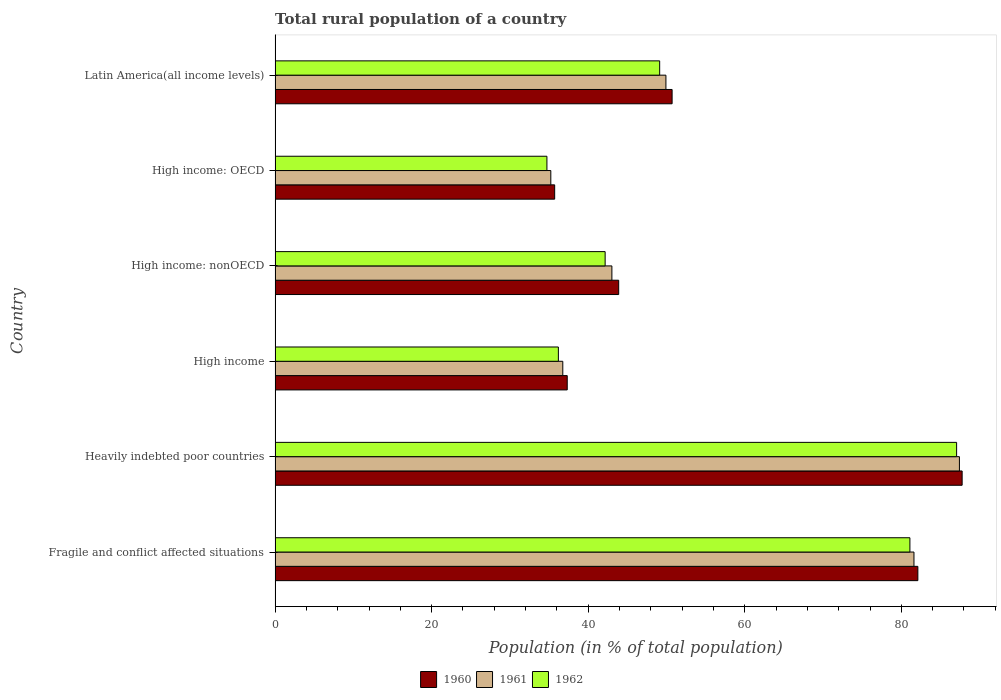How many groups of bars are there?
Your response must be concise. 6. Are the number of bars per tick equal to the number of legend labels?
Provide a short and direct response. Yes. How many bars are there on the 2nd tick from the top?
Make the answer very short. 3. What is the label of the 1st group of bars from the top?
Your answer should be very brief. Latin America(all income levels). What is the rural population in 1960 in Latin America(all income levels)?
Your response must be concise. 50.72. Across all countries, what is the maximum rural population in 1960?
Make the answer very short. 87.76. Across all countries, what is the minimum rural population in 1962?
Your answer should be very brief. 34.72. In which country was the rural population in 1962 maximum?
Offer a very short reply. Heavily indebted poor countries. In which country was the rural population in 1961 minimum?
Offer a terse response. High income: OECD. What is the total rural population in 1960 in the graph?
Ensure brevity in your answer.  337.51. What is the difference between the rural population in 1961 in High income: OECD and that in High income: nonOECD?
Offer a very short reply. -7.8. What is the difference between the rural population in 1961 in High income and the rural population in 1960 in Latin America(all income levels)?
Give a very brief answer. -13.96. What is the average rural population in 1962 per country?
Provide a succinct answer. 55.06. What is the difference between the rural population in 1961 and rural population in 1960 in High income: nonOECD?
Provide a succinct answer. -0.87. In how many countries, is the rural population in 1961 greater than 24 %?
Your answer should be compact. 6. What is the ratio of the rural population in 1962 in Fragile and conflict affected situations to that in Latin America(all income levels)?
Provide a short and direct response. 1.65. What is the difference between the highest and the second highest rural population in 1962?
Your answer should be compact. 5.97. What is the difference between the highest and the lowest rural population in 1960?
Offer a very short reply. 52.05. What does the 2nd bar from the top in High income: nonOECD represents?
Your response must be concise. 1961. What does the 3rd bar from the bottom in Fragile and conflict affected situations represents?
Offer a very short reply. 1962. Is it the case that in every country, the sum of the rural population in 1962 and rural population in 1960 is greater than the rural population in 1961?
Your response must be concise. Yes. Are all the bars in the graph horizontal?
Provide a succinct answer. Yes. How many countries are there in the graph?
Your answer should be compact. 6. Are the values on the major ticks of X-axis written in scientific E-notation?
Offer a very short reply. No. Does the graph contain any zero values?
Give a very brief answer. No. Does the graph contain grids?
Give a very brief answer. No. Where does the legend appear in the graph?
Offer a very short reply. Bottom center. What is the title of the graph?
Ensure brevity in your answer.  Total rural population of a country. What is the label or title of the X-axis?
Ensure brevity in your answer.  Population (in % of total population). What is the label or title of the Y-axis?
Make the answer very short. Country. What is the Population (in % of total population) in 1960 in Fragile and conflict affected situations?
Offer a very short reply. 82.11. What is the Population (in % of total population) of 1961 in Fragile and conflict affected situations?
Make the answer very short. 81.61. What is the Population (in % of total population) in 1962 in Fragile and conflict affected situations?
Offer a very short reply. 81.09. What is the Population (in % of total population) of 1960 in Heavily indebted poor countries?
Offer a terse response. 87.76. What is the Population (in % of total population) in 1961 in Heavily indebted poor countries?
Make the answer very short. 87.42. What is the Population (in % of total population) in 1962 in Heavily indebted poor countries?
Make the answer very short. 87.06. What is the Population (in % of total population) of 1960 in High income?
Your answer should be compact. 37.32. What is the Population (in % of total population) in 1961 in High income?
Offer a terse response. 36.75. What is the Population (in % of total population) of 1962 in High income?
Your answer should be compact. 36.19. What is the Population (in % of total population) of 1960 in High income: nonOECD?
Your response must be concise. 43.89. What is the Population (in % of total population) in 1961 in High income: nonOECD?
Ensure brevity in your answer.  43.02. What is the Population (in % of total population) of 1962 in High income: nonOECD?
Offer a very short reply. 42.16. What is the Population (in % of total population) of 1960 in High income: OECD?
Your response must be concise. 35.71. What is the Population (in % of total population) of 1961 in High income: OECD?
Make the answer very short. 35.22. What is the Population (in % of total population) in 1962 in High income: OECD?
Your response must be concise. 34.72. What is the Population (in % of total population) in 1960 in Latin America(all income levels)?
Your answer should be very brief. 50.72. What is the Population (in % of total population) of 1961 in Latin America(all income levels)?
Ensure brevity in your answer.  49.93. What is the Population (in % of total population) in 1962 in Latin America(all income levels)?
Give a very brief answer. 49.13. Across all countries, what is the maximum Population (in % of total population) in 1960?
Provide a succinct answer. 87.76. Across all countries, what is the maximum Population (in % of total population) in 1961?
Make the answer very short. 87.42. Across all countries, what is the maximum Population (in % of total population) in 1962?
Make the answer very short. 87.06. Across all countries, what is the minimum Population (in % of total population) in 1960?
Your answer should be compact. 35.71. Across all countries, what is the minimum Population (in % of total population) in 1961?
Your answer should be very brief. 35.22. Across all countries, what is the minimum Population (in % of total population) of 1962?
Ensure brevity in your answer.  34.72. What is the total Population (in % of total population) of 1960 in the graph?
Keep it short and to the point. 337.51. What is the total Population (in % of total population) in 1961 in the graph?
Make the answer very short. 333.95. What is the total Population (in % of total population) of 1962 in the graph?
Your response must be concise. 330.35. What is the difference between the Population (in % of total population) of 1960 in Fragile and conflict affected situations and that in Heavily indebted poor countries?
Give a very brief answer. -5.66. What is the difference between the Population (in % of total population) of 1961 in Fragile and conflict affected situations and that in Heavily indebted poor countries?
Keep it short and to the point. -5.81. What is the difference between the Population (in % of total population) of 1962 in Fragile and conflict affected situations and that in Heavily indebted poor countries?
Your response must be concise. -5.97. What is the difference between the Population (in % of total population) of 1960 in Fragile and conflict affected situations and that in High income?
Ensure brevity in your answer.  44.79. What is the difference between the Population (in % of total population) in 1961 in Fragile and conflict affected situations and that in High income?
Give a very brief answer. 44.86. What is the difference between the Population (in % of total population) of 1962 in Fragile and conflict affected situations and that in High income?
Make the answer very short. 44.91. What is the difference between the Population (in % of total population) in 1960 in Fragile and conflict affected situations and that in High income: nonOECD?
Keep it short and to the point. 38.22. What is the difference between the Population (in % of total population) of 1961 in Fragile and conflict affected situations and that in High income: nonOECD?
Ensure brevity in your answer.  38.59. What is the difference between the Population (in % of total population) in 1962 in Fragile and conflict affected situations and that in High income: nonOECD?
Your answer should be compact. 38.93. What is the difference between the Population (in % of total population) of 1960 in Fragile and conflict affected situations and that in High income: OECD?
Give a very brief answer. 46.39. What is the difference between the Population (in % of total population) in 1961 in Fragile and conflict affected situations and that in High income: OECD?
Keep it short and to the point. 46.39. What is the difference between the Population (in % of total population) in 1962 in Fragile and conflict affected situations and that in High income: OECD?
Provide a short and direct response. 46.37. What is the difference between the Population (in % of total population) of 1960 in Fragile and conflict affected situations and that in Latin America(all income levels)?
Ensure brevity in your answer.  31.39. What is the difference between the Population (in % of total population) in 1961 in Fragile and conflict affected situations and that in Latin America(all income levels)?
Ensure brevity in your answer.  31.68. What is the difference between the Population (in % of total population) of 1962 in Fragile and conflict affected situations and that in Latin America(all income levels)?
Keep it short and to the point. 31.97. What is the difference between the Population (in % of total population) of 1960 in Heavily indebted poor countries and that in High income?
Keep it short and to the point. 50.44. What is the difference between the Population (in % of total population) in 1961 in Heavily indebted poor countries and that in High income?
Keep it short and to the point. 50.66. What is the difference between the Population (in % of total population) of 1962 in Heavily indebted poor countries and that in High income?
Provide a succinct answer. 50.87. What is the difference between the Population (in % of total population) of 1960 in Heavily indebted poor countries and that in High income: nonOECD?
Make the answer very short. 43.87. What is the difference between the Population (in % of total population) in 1961 in Heavily indebted poor countries and that in High income: nonOECD?
Your response must be concise. 44.39. What is the difference between the Population (in % of total population) of 1962 in Heavily indebted poor countries and that in High income: nonOECD?
Ensure brevity in your answer.  44.9. What is the difference between the Population (in % of total population) in 1960 in Heavily indebted poor countries and that in High income: OECD?
Ensure brevity in your answer.  52.05. What is the difference between the Population (in % of total population) of 1961 in Heavily indebted poor countries and that in High income: OECD?
Offer a terse response. 52.2. What is the difference between the Population (in % of total population) of 1962 in Heavily indebted poor countries and that in High income: OECD?
Provide a succinct answer. 52.33. What is the difference between the Population (in % of total population) in 1960 in Heavily indebted poor countries and that in Latin America(all income levels)?
Ensure brevity in your answer.  37.05. What is the difference between the Population (in % of total population) of 1961 in Heavily indebted poor countries and that in Latin America(all income levels)?
Provide a short and direct response. 37.49. What is the difference between the Population (in % of total population) in 1962 in Heavily indebted poor countries and that in Latin America(all income levels)?
Make the answer very short. 37.93. What is the difference between the Population (in % of total population) in 1960 in High income and that in High income: nonOECD?
Offer a terse response. -6.57. What is the difference between the Population (in % of total population) in 1961 in High income and that in High income: nonOECD?
Offer a very short reply. -6.27. What is the difference between the Population (in % of total population) in 1962 in High income and that in High income: nonOECD?
Provide a short and direct response. -5.97. What is the difference between the Population (in % of total population) in 1960 in High income and that in High income: OECD?
Provide a succinct answer. 1.61. What is the difference between the Population (in % of total population) of 1961 in High income and that in High income: OECD?
Give a very brief answer. 1.53. What is the difference between the Population (in % of total population) in 1962 in High income and that in High income: OECD?
Provide a succinct answer. 1.46. What is the difference between the Population (in % of total population) in 1960 in High income and that in Latin America(all income levels)?
Keep it short and to the point. -13.4. What is the difference between the Population (in % of total population) in 1961 in High income and that in Latin America(all income levels)?
Ensure brevity in your answer.  -13.17. What is the difference between the Population (in % of total population) of 1962 in High income and that in Latin America(all income levels)?
Offer a very short reply. -12.94. What is the difference between the Population (in % of total population) of 1960 in High income: nonOECD and that in High income: OECD?
Keep it short and to the point. 8.18. What is the difference between the Population (in % of total population) of 1961 in High income: nonOECD and that in High income: OECD?
Offer a very short reply. 7.8. What is the difference between the Population (in % of total population) in 1962 in High income: nonOECD and that in High income: OECD?
Keep it short and to the point. 7.44. What is the difference between the Population (in % of total population) of 1960 in High income: nonOECD and that in Latin America(all income levels)?
Keep it short and to the point. -6.82. What is the difference between the Population (in % of total population) of 1961 in High income: nonOECD and that in Latin America(all income levels)?
Offer a terse response. -6.9. What is the difference between the Population (in % of total population) of 1962 in High income: nonOECD and that in Latin America(all income levels)?
Ensure brevity in your answer.  -6.97. What is the difference between the Population (in % of total population) in 1960 in High income: OECD and that in Latin America(all income levels)?
Your answer should be compact. -15. What is the difference between the Population (in % of total population) of 1961 in High income: OECD and that in Latin America(all income levels)?
Keep it short and to the point. -14.71. What is the difference between the Population (in % of total population) of 1962 in High income: OECD and that in Latin America(all income levels)?
Offer a very short reply. -14.4. What is the difference between the Population (in % of total population) of 1960 in Fragile and conflict affected situations and the Population (in % of total population) of 1961 in Heavily indebted poor countries?
Provide a succinct answer. -5.31. What is the difference between the Population (in % of total population) of 1960 in Fragile and conflict affected situations and the Population (in % of total population) of 1962 in Heavily indebted poor countries?
Your answer should be compact. -4.95. What is the difference between the Population (in % of total population) in 1961 in Fragile and conflict affected situations and the Population (in % of total population) in 1962 in Heavily indebted poor countries?
Make the answer very short. -5.45. What is the difference between the Population (in % of total population) of 1960 in Fragile and conflict affected situations and the Population (in % of total population) of 1961 in High income?
Give a very brief answer. 45.35. What is the difference between the Population (in % of total population) in 1960 in Fragile and conflict affected situations and the Population (in % of total population) in 1962 in High income?
Your answer should be very brief. 45.92. What is the difference between the Population (in % of total population) of 1961 in Fragile and conflict affected situations and the Population (in % of total population) of 1962 in High income?
Offer a very short reply. 45.42. What is the difference between the Population (in % of total population) of 1960 in Fragile and conflict affected situations and the Population (in % of total population) of 1961 in High income: nonOECD?
Your response must be concise. 39.08. What is the difference between the Population (in % of total population) of 1960 in Fragile and conflict affected situations and the Population (in % of total population) of 1962 in High income: nonOECD?
Ensure brevity in your answer.  39.95. What is the difference between the Population (in % of total population) in 1961 in Fragile and conflict affected situations and the Population (in % of total population) in 1962 in High income: nonOECD?
Make the answer very short. 39.45. What is the difference between the Population (in % of total population) in 1960 in Fragile and conflict affected situations and the Population (in % of total population) in 1961 in High income: OECD?
Give a very brief answer. 46.89. What is the difference between the Population (in % of total population) of 1960 in Fragile and conflict affected situations and the Population (in % of total population) of 1962 in High income: OECD?
Keep it short and to the point. 47.38. What is the difference between the Population (in % of total population) of 1961 in Fragile and conflict affected situations and the Population (in % of total population) of 1962 in High income: OECD?
Make the answer very short. 46.89. What is the difference between the Population (in % of total population) in 1960 in Fragile and conflict affected situations and the Population (in % of total population) in 1961 in Latin America(all income levels)?
Your response must be concise. 32.18. What is the difference between the Population (in % of total population) in 1960 in Fragile and conflict affected situations and the Population (in % of total population) in 1962 in Latin America(all income levels)?
Offer a terse response. 32.98. What is the difference between the Population (in % of total population) in 1961 in Fragile and conflict affected situations and the Population (in % of total population) in 1962 in Latin America(all income levels)?
Your answer should be very brief. 32.48. What is the difference between the Population (in % of total population) in 1960 in Heavily indebted poor countries and the Population (in % of total population) in 1961 in High income?
Give a very brief answer. 51.01. What is the difference between the Population (in % of total population) of 1960 in Heavily indebted poor countries and the Population (in % of total population) of 1962 in High income?
Provide a succinct answer. 51.58. What is the difference between the Population (in % of total population) of 1961 in Heavily indebted poor countries and the Population (in % of total population) of 1962 in High income?
Give a very brief answer. 51.23. What is the difference between the Population (in % of total population) of 1960 in Heavily indebted poor countries and the Population (in % of total population) of 1961 in High income: nonOECD?
Ensure brevity in your answer.  44.74. What is the difference between the Population (in % of total population) in 1960 in Heavily indebted poor countries and the Population (in % of total population) in 1962 in High income: nonOECD?
Your answer should be compact. 45.6. What is the difference between the Population (in % of total population) in 1961 in Heavily indebted poor countries and the Population (in % of total population) in 1962 in High income: nonOECD?
Give a very brief answer. 45.26. What is the difference between the Population (in % of total population) of 1960 in Heavily indebted poor countries and the Population (in % of total population) of 1961 in High income: OECD?
Give a very brief answer. 52.54. What is the difference between the Population (in % of total population) in 1960 in Heavily indebted poor countries and the Population (in % of total population) in 1962 in High income: OECD?
Keep it short and to the point. 53.04. What is the difference between the Population (in % of total population) of 1961 in Heavily indebted poor countries and the Population (in % of total population) of 1962 in High income: OECD?
Provide a short and direct response. 52.69. What is the difference between the Population (in % of total population) of 1960 in Heavily indebted poor countries and the Population (in % of total population) of 1961 in Latin America(all income levels)?
Your answer should be compact. 37.84. What is the difference between the Population (in % of total population) of 1960 in Heavily indebted poor countries and the Population (in % of total population) of 1962 in Latin America(all income levels)?
Ensure brevity in your answer.  38.64. What is the difference between the Population (in % of total population) in 1961 in Heavily indebted poor countries and the Population (in % of total population) in 1962 in Latin America(all income levels)?
Make the answer very short. 38.29. What is the difference between the Population (in % of total population) in 1960 in High income and the Population (in % of total population) in 1961 in High income: nonOECD?
Offer a very short reply. -5.7. What is the difference between the Population (in % of total population) of 1960 in High income and the Population (in % of total population) of 1962 in High income: nonOECD?
Keep it short and to the point. -4.84. What is the difference between the Population (in % of total population) of 1961 in High income and the Population (in % of total population) of 1962 in High income: nonOECD?
Offer a very short reply. -5.41. What is the difference between the Population (in % of total population) of 1960 in High income and the Population (in % of total population) of 1961 in High income: OECD?
Ensure brevity in your answer.  2.1. What is the difference between the Population (in % of total population) of 1960 in High income and the Population (in % of total population) of 1962 in High income: OECD?
Provide a short and direct response. 2.6. What is the difference between the Population (in % of total population) of 1961 in High income and the Population (in % of total population) of 1962 in High income: OECD?
Your answer should be very brief. 2.03. What is the difference between the Population (in % of total population) in 1960 in High income and the Population (in % of total population) in 1961 in Latin America(all income levels)?
Provide a succinct answer. -12.61. What is the difference between the Population (in % of total population) of 1960 in High income and the Population (in % of total population) of 1962 in Latin America(all income levels)?
Your answer should be very brief. -11.81. What is the difference between the Population (in % of total population) of 1961 in High income and the Population (in % of total population) of 1962 in Latin America(all income levels)?
Offer a terse response. -12.37. What is the difference between the Population (in % of total population) of 1960 in High income: nonOECD and the Population (in % of total population) of 1961 in High income: OECD?
Provide a short and direct response. 8.67. What is the difference between the Population (in % of total population) in 1960 in High income: nonOECD and the Population (in % of total population) in 1962 in High income: OECD?
Offer a very short reply. 9.17. What is the difference between the Population (in % of total population) of 1961 in High income: nonOECD and the Population (in % of total population) of 1962 in High income: OECD?
Your answer should be very brief. 8.3. What is the difference between the Population (in % of total population) of 1960 in High income: nonOECD and the Population (in % of total population) of 1961 in Latin America(all income levels)?
Give a very brief answer. -6.03. What is the difference between the Population (in % of total population) in 1960 in High income: nonOECD and the Population (in % of total population) in 1962 in Latin America(all income levels)?
Ensure brevity in your answer.  -5.24. What is the difference between the Population (in % of total population) of 1961 in High income: nonOECD and the Population (in % of total population) of 1962 in Latin America(all income levels)?
Ensure brevity in your answer.  -6.1. What is the difference between the Population (in % of total population) of 1960 in High income: OECD and the Population (in % of total population) of 1961 in Latin America(all income levels)?
Offer a terse response. -14.21. What is the difference between the Population (in % of total population) in 1960 in High income: OECD and the Population (in % of total population) in 1962 in Latin America(all income levels)?
Your response must be concise. -13.41. What is the difference between the Population (in % of total population) in 1961 in High income: OECD and the Population (in % of total population) in 1962 in Latin America(all income levels)?
Provide a short and direct response. -13.91. What is the average Population (in % of total population) in 1960 per country?
Offer a terse response. 56.25. What is the average Population (in % of total population) of 1961 per country?
Provide a short and direct response. 55.66. What is the average Population (in % of total population) in 1962 per country?
Keep it short and to the point. 55.06. What is the difference between the Population (in % of total population) in 1960 and Population (in % of total population) in 1961 in Fragile and conflict affected situations?
Make the answer very short. 0.5. What is the difference between the Population (in % of total population) in 1960 and Population (in % of total population) in 1962 in Fragile and conflict affected situations?
Provide a short and direct response. 1.02. What is the difference between the Population (in % of total population) of 1961 and Population (in % of total population) of 1962 in Fragile and conflict affected situations?
Make the answer very short. 0.52. What is the difference between the Population (in % of total population) in 1960 and Population (in % of total population) in 1961 in Heavily indebted poor countries?
Provide a succinct answer. 0.35. What is the difference between the Population (in % of total population) of 1960 and Population (in % of total population) of 1962 in Heavily indebted poor countries?
Offer a very short reply. 0.71. What is the difference between the Population (in % of total population) in 1961 and Population (in % of total population) in 1962 in Heavily indebted poor countries?
Ensure brevity in your answer.  0.36. What is the difference between the Population (in % of total population) in 1960 and Population (in % of total population) in 1961 in High income?
Keep it short and to the point. 0.57. What is the difference between the Population (in % of total population) in 1960 and Population (in % of total population) in 1962 in High income?
Your answer should be compact. 1.13. What is the difference between the Population (in % of total population) in 1961 and Population (in % of total population) in 1962 in High income?
Provide a succinct answer. 0.57. What is the difference between the Population (in % of total population) in 1960 and Population (in % of total population) in 1961 in High income: nonOECD?
Offer a terse response. 0.87. What is the difference between the Population (in % of total population) in 1960 and Population (in % of total population) in 1962 in High income: nonOECD?
Provide a succinct answer. 1.73. What is the difference between the Population (in % of total population) of 1961 and Population (in % of total population) of 1962 in High income: nonOECD?
Keep it short and to the point. 0.86. What is the difference between the Population (in % of total population) in 1960 and Population (in % of total population) in 1961 in High income: OECD?
Offer a terse response. 0.49. What is the difference between the Population (in % of total population) in 1961 and Population (in % of total population) in 1962 in High income: OECD?
Your response must be concise. 0.5. What is the difference between the Population (in % of total population) of 1960 and Population (in % of total population) of 1961 in Latin America(all income levels)?
Keep it short and to the point. 0.79. What is the difference between the Population (in % of total population) of 1960 and Population (in % of total population) of 1962 in Latin America(all income levels)?
Provide a short and direct response. 1.59. What is the difference between the Population (in % of total population) in 1961 and Population (in % of total population) in 1962 in Latin America(all income levels)?
Your answer should be compact. 0.8. What is the ratio of the Population (in % of total population) in 1960 in Fragile and conflict affected situations to that in Heavily indebted poor countries?
Provide a short and direct response. 0.94. What is the ratio of the Population (in % of total population) in 1961 in Fragile and conflict affected situations to that in Heavily indebted poor countries?
Your answer should be compact. 0.93. What is the ratio of the Population (in % of total population) in 1962 in Fragile and conflict affected situations to that in Heavily indebted poor countries?
Offer a very short reply. 0.93. What is the ratio of the Population (in % of total population) in 1960 in Fragile and conflict affected situations to that in High income?
Give a very brief answer. 2.2. What is the ratio of the Population (in % of total population) in 1961 in Fragile and conflict affected situations to that in High income?
Offer a very short reply. 2.22. What is the ratio of the Population (in % of total population) in 1962 in Fragile and conflict affected situations to that in High income?
Your answer should be very brief. 2.24. What is the ratio of the Population (in % of total population) of 1960 in Fragile and conflict affected situations to that in High income: nonOECD?
Offer a very short reply. 1.87. What is the ratio of the Population (in % of total population) of 1961 in Fragile and conflict affected situations to that in High income: nonOECD?
Keep it short and to the point. 1.9. What is the ratio of the Population (in % of total population) of 1962 in Fragile and conflict affected situations to that in High income: nonOECD?
Ensure brevity in your answer.  1.92. What is the ratio of the Population (in % of total population) in 1960 in Fragile and conflict affected situations to that in High income: OECD?
Make the answer very short. 2.3. What is the ratio of the Population (in % of total population) in 1961 in Fragile and conflict affected situations to that in High income: OECD?
Keep it short and to the point. 2.32. What is the ratio of the Population (in % of total population) of 1962 in Fragile and conflict affected situations to that in High income: OECD?
Offer a very short reply. 2.34. What is the ratio of the Population (in % of total population) in 1960 in Fragile and conflict affected situations to that in Latin America(all income levels)?
Provide a succinct answer. 1.62. What is the ratio of the Population (in % of total population) of 1961 in Fragile and conflict affected situations to that in Latin America(all income levels)?
Offer a terse response. 1.63. What is the ratio of the Population (in % of total population) of 1962 in Fragile and conflict affected situations to that in Latin America(all income levels)?
Give a very brief answer. 1.65. What is the ratio of the Population (in % of total population) in 1960 in Heavily indebted poor countries to that in High income?
Your answer should be very brief. 2.35. What is the ratio of the Population (in % of total population) in 1961 in Heavily indebted poor countries to that in High income?
Keep it short and to the point. 2.38. What is the ratio of the Population (in % of total population) of 1962 in Heavily indebted poor countries to that in High income?
Your answer should be very brief. 2.41. What is the ratio of the Population (in % of total population) in 1960 in Heavily indebted poor countries to that in High income: nonOECD?
Provide a succinct answer. 2. What is the ratio of the Population (in % of total population) of 1961 in Heavily indebted poor countries to that in High income: nonOECD?
Your answer should be compact. 2.03. What is the ratio of the Population (in % of total population) in 1962 in Heavily indebted poor countries to that in High income: nonOECD?
Offer a very short reply. 2.06. What is the ratio of the Population (in % of total population) in 1960 in Heavily indebted poor countries to that in High income: OECD?
Provide a succinct answer. 2.46. What is the ratio of the Population (in % of total population) of 1961 in Heavily indebted poor countries to that in High income: OECD?
Make the answer very short. 2.48. What is the ratio of the Population (in % of total population) of 1962 in Heavily indebted poor countries to that in High income: OECD?
Keep it short and to the point. 2.51. What is the ratio of the Population (in % of total population) of 1960 in Heavily indebted poor countries to that in Latin America(all income levels)?
Offer a terse response. 1.73. What is the ratio of the Population (in % of total population) in 1961 in Heavily indebted poor countries to that in Latin America(all income levels)?
Your answer should be very brief. 1.75. What is the ratio of the Population (in % of total population) of 1962 in Heavily indebted poor countries to that in Latin America(all income levels)?
Your answer should be compact. 1.77. What is the ratio of the Population (in % of total population) of 1960 in High income to that in High income: nonOECD?
Keep it short and to the point. 0.85. What is the ratio of the Population (in % of total population) in 1961 in High income to that in High income: nonOECD?
Your answer should be very brief. 0.85. What is the ratio of the Population (in % of total population) in 1962 in High income to that in High income: nonOECD?
Provide a short and direct response. 0.86. What is the ratio of the Population (in % of total population) in 1960 in High income to that in High income: OECD?
Your response must be concise. 1.04. What is the ratio of the Population (in % of total population) in 1961 in High income to that in High income: OECD?
Offer a terse response. 1.04. What is the ratio of the Population (in % of total population) in 1962 in High income to that in High income: OECD?
Ensure brevity in your answer.  1.04. What is the ratio of the Population (in % of total population) in 1960 in High income to that in Latin America(all income levels)?
Your answer should be compact. 0.74. What is the ratio of the Population (in % of total population) of 1961 in High income to that in Latin America(all income levels)?
Make the answer very short. 0.74. What is the ratio of the Population (in % of total population) in 1962 in High income to that in Latin America(all income levels)?
Offer a terse response. 0.74. What is the ratio of the Population (in % of total population) in 1960 in High income: nonOECD to that in High income: OECD?
Ensure brevity in your answer.  1.23. What is the ratio of the Population (in % of total population) of 1961 in High income: nonOECD to that in High income: OECD?
Your response must be concise. 1.22. What is the ratio of the Population (in % of total population) of 1962 in High income: nonOECD to that in High income: OECD?
Make the answer very short. 1.21. What is the ratio of the Population (in % of total population) of 1960 in High income: nonOECD to that in Latin America(all income levels)?
Keep it short and to the point. 0.87. What is the ratio of the Population (in % of total population) in 1961 in High income: nonOECD to that in Latin America(all income levels)?
Your answer should be compact. 0.86. What is the ratio of the Population (in % of total population) of 1962 in High income: nonOECD to that in Latin America(all income levels)?
Provide a succinct answer. 0.86. What is the ratio of the Population (in % of total population) of 1960 in High income: OECD to that in Latin America(all income levels)?
Provide a succinct answer. 0.7. What is the ratio of the Population (in % of total population) in 1961 in High income: OECD to that in Latin America(all income levels)?
Your answer should be compact. 0.71. What is the ratio of the Population (in % of total population) of 1962 in High income: OECD to that in Latin America(all income levels)?
Ensure brevity in your answer.  0.71. What is the difference between the highest and the second highest Population (in % of total population) of 1960?
Provide a succinct answer. 5.66. What is the difference between the highest and the second highest Population (in % of total population) of 1961?
Offer a terse response. 5.81. What is the difference between the highest and the second highest Population (in % of total population) in 1962?
Make the answer very short. 5.97. What is the difference between the highest and the lowest Population (in % of total population) in 1960?
Offer a terse response. 52.05. What is the difference between the highest and the lowest Population (in % of total population) in 1961?
Provide a short and direct response. 52.2. What is the difference between the highest and the lowest Population (in % of total population) in 1962?
Give a very brief answer. 52.33. 